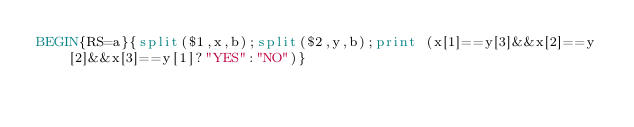Convert code to text. <code><loc_0><loc_0><loc_500><loc_500><_Awk_>BEGIN{RS=a}{split($1,x,b);split($2,y,b);print (x[1]==y[3]&&x[2]==y[2]&&x[3]==y[1]?"YES":"NO")}</code> 